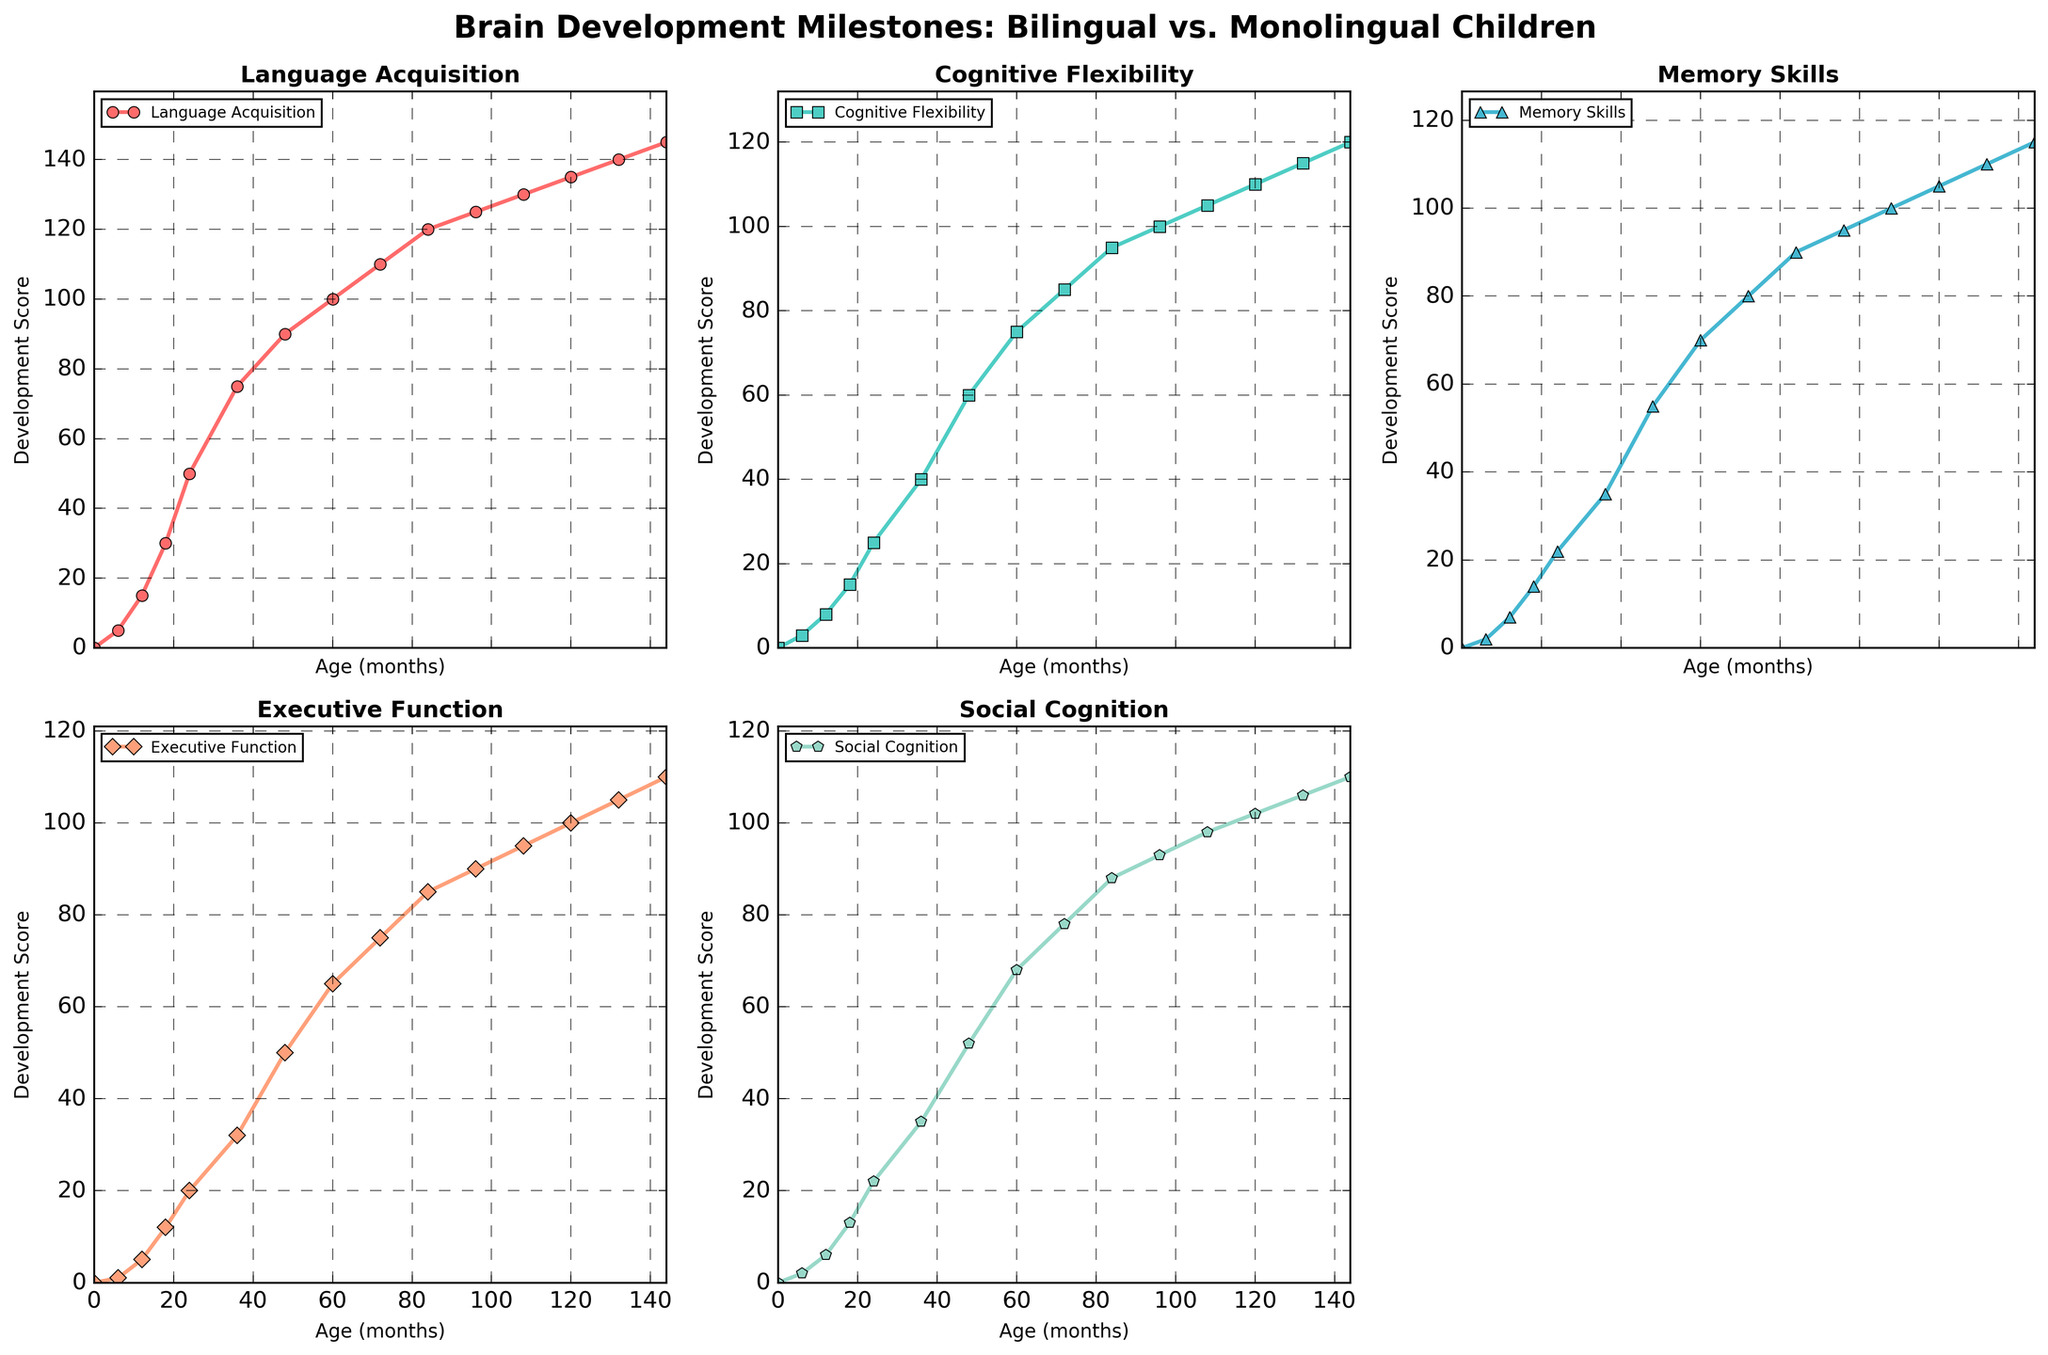What's the maximum value of the Language Acquisition line chart? The maximum value for the Language Acquisition line chart is the highest point reached on the Y-axis within the Language Acquisition subplot. The highest value reached by the Language Acquisition line is 145 at 144 months.
Answer: 145 How does Executive Function develop from 18 to 48 months? To examine the development of Executive Function from 18 to 48 months, find the values at 18 months and 48 months and observe the trend between these points. At 18 months, the score is 12, and at 48 months, the score is 50. The score increases consistently over this period.
Answer: It increases from 12 to 50 Which skill shows the steepest growth between infancy (0 months) and early childhood (24 months)? Compare the increments in the values of each skill from their zero points to the values at 24 months. Language Acquisition increases from 0 to 50, Cognitive Flexibility from 0 to 25, Memory Skills from 0 to 22, Executive Function from 0 to 20, and Social Cognition from 0 to 22. The steepest growth is in Language Acquisition (increase of 50).
Answer: Language Acquisition At what age do Cognitive Flexibility and Memory Skills have equal scores? Find the intersection point of the lines representing Cognitive Flexibility and Memory Skills. Observing the chart, the lines for Cognitive Flexibility and Memory Skills intersect at around 96 months with both values being approximately 95.
Answer: 96 months Which skill has the smallest value at 72 months? Identify the values of all skills at 72 months and determine which one is the lowest. Language Acquisition is at 110, Cognitive Flexibility at 85, Memory Skills at 80, Executive Function at 75, and Social Cognition at 78. The smallest value is in Executive Function.
Answer: Executive Function How much does Social Cognition score increase from 12 to 60 months? Calculate the difference between the Social Cognition values at 12 months and 60 months. Social Cognition at 12 months is 6 and at 60 months is 68. The increase is 68 - 6 = 62.
Answer: 62 How does the development trend of Social Cognition compare to Executive Function in the first 3 years? Compare the lines for Social Cognition and Executive Function from 0 to 36 months. Social Cognition starts at 0, reaches 2 at 6 months, 6 at 12 months, 13 at 18 months, 22 at 24 months, and 35 at 36 months. Executive Function starts at 0, reaches 1 at 6 months, 5 at 12 months, 12 at 18 months, 20 at 24 months, and 32 at 36 months. Social Cognition increases more steadily and slightly higher than Executive Function.
Answer: Social Cognition increases at a slightly higher rate Which skill does not surpass a value of 100 by 108 months? Identify the values of each skill at 108 months and check if any do not exceed 100. At 108 months, Language Acquisition is 130, Cognitive Flexibility is 105, Memory Skills is 100, Executive Function is 95, and Social Cognition is 98. Executive Function and Social Cognition do not surpass 100.
Answer: Executive Function and Social Cognition What is the overall trend for Memory Skills from infancy to adolescence? Observe the line representing Memory Skills from the start (0 months) to the end (144 months). It consistently increases, starting at 0 and reaching 115, indicating a continuous upward trend.
Answer: Continuous upward trend 